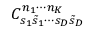Convert formula to latex. <formula><loc_0><loc_0><loc_500><loc_500>C _ { s _ { 1 } \tilde { s } _ { 1 } \cdots s _ { D } \tilde { s } _ { D } } ^ { n _ { 1 } \cdots n _ { K } }</formula> 